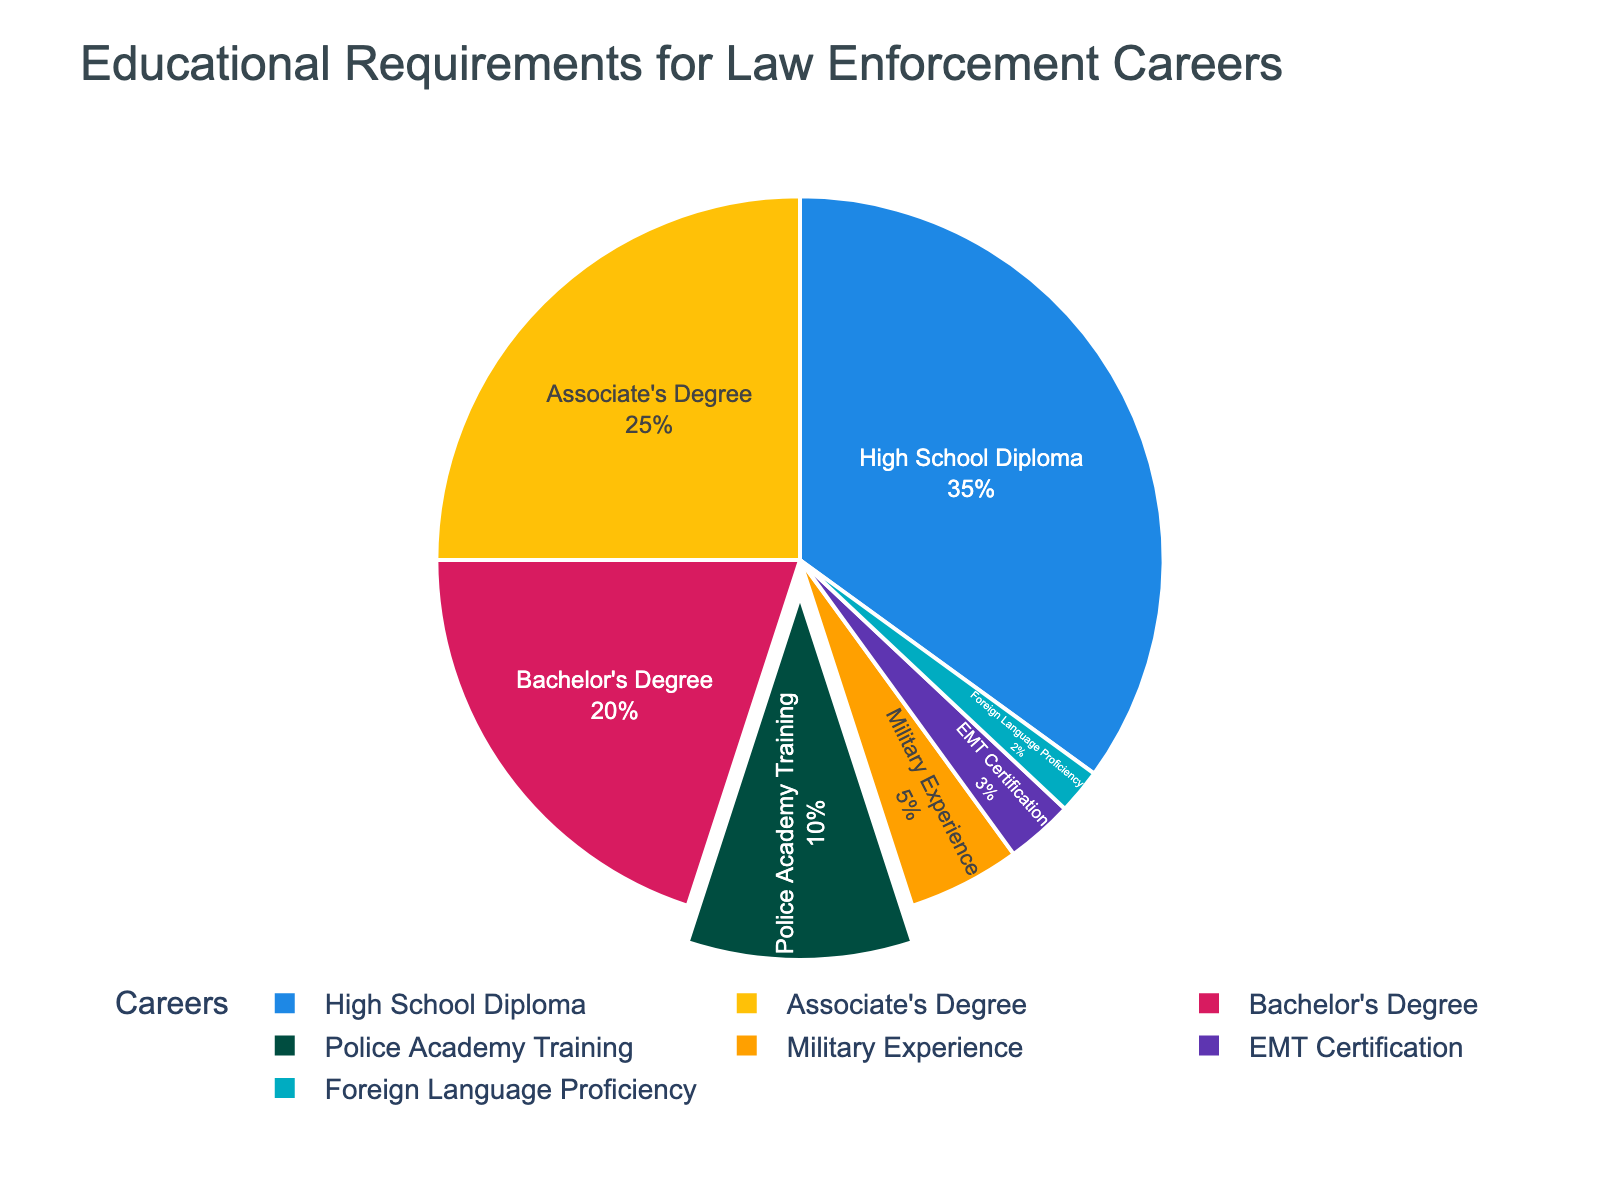What percentage of law enforcement careers require a high school diploma? The high school diploma requirement is represented by a segment marked with 35%. This is directly indicated on the pie chart as one of the labels.
Answer: 35% Which career category has the smallest representation in the pie chart? The career category with the smallest representation can be identified by finding the segment with the smallest percentage. The chart shows Foreign Language Proficiency as 2%, which is the smallest value.
Answer: Foreign Language Proficiency How does the percentage of careers requiring a Bachelor's Degree compare to those requiring a High School Diploma? The percentage for a Bachelor's Degree is 20%, and for a High School Diploma, it is 35%. Comparing these, 35% is greater than 20%.
Answer: Bachelor's Degree is less than High School Diploma What career categories make up over half of the chart combined? To determine which categories combined make up over half the chart, we identify the largest segments and sum their percentages until the total exceeds 50%. High School Diploma (35%) + Associate's Degree (25%) sums to 60%, which is over half.
Answer: High School Diploma and Associate's Degree Which educational requirement has a distinct visual pull-out effect in the pie chart? Noticing the visual aspect, the "Police Academy Training" segment appears slightly pulled out from the rest. This distinct separation makes it visually stand out.
Answer: Police Academy Training How many career categories together make up 70% of the total? We start summing the largest categories until reaching 70%. High School Diploma (35%) + Associate's Degree (25%) equals 60%. Adding Bachelor's Degree (20%) brings it to 80%. Therefore, the first three categories surpass 70%.
Answer: Three categories Rank the top three educational requirements in order of their percentage representation. If we list by descending percentages: 1) High School Diploma (35%), 2) Associate's Degree (25%), 3) Bachelor's Degree (20%).
Answer: High School Diploma, Associate's Degree, Bachelor's Degree What’s the combined percentage of careers requiring specific training or experience, like Police Academy Training and Military Experience? Adding the percentages for Police Academy Training (10%) and Military Experience (5%) gives a total of 15%.
Answer: 15% Does the requirement for an EMT certification exceed that of Foreign Language Proficiency? Comparing the percentages, EMT Certification is 3%, whereas Foreign Language Proficiency is 2%, making EMT Certification greater.
Answer: Yes What percentage is represented by requirements other than a High School Diploma and Associate's Degree? First, add the percentages of High School Diploma (35%) and Associate’s Degree (25%) to get 60%. Subtracting this from 100% gives 40% for the remaining categories.
Answer: 40% 